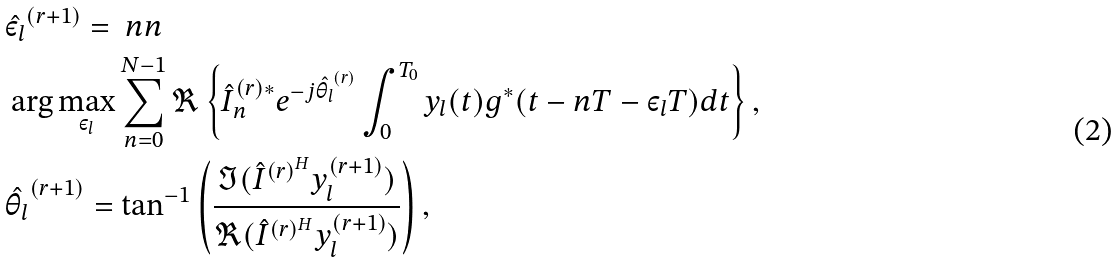Convert formula to latex. <formula><loc_0><loc_0><loc_500><loc_500>& \hat { \varepsilon _ { l } } ^ { ( r + 1 ) } = \ n n \\ & \arg \max _ { \varepsilon _ { l } } \sum _ { n = 0 } ^ { N - 1 } \Re \left \{ \hat { I } _ { n } ^ { ( r ) * } e ^ { - j \hat { \theta _ { l } } ^ { ( r ) } } \int _ { 0 } ^ { T _ { 0 } } y _ { l } ( t ) g ^ { * } ( t - n T - \varepsilon _ { l } T ) d t \right \} , \\ & \hat { \theta _ { l } } ^ { ( r + 1 ) } = \tan ^ { - 1 } \left ( \frac { \Im ( \hat { I } ^ { ( r ) ^ { H } } y _ { l } ^ { ( r + 1 ) } ) } { \Re ( \hat { I } ^ { ( r ) ^ { H } } y _ { l } ^ { ( r + 1 ) } ) } \right ) ,</formula> 